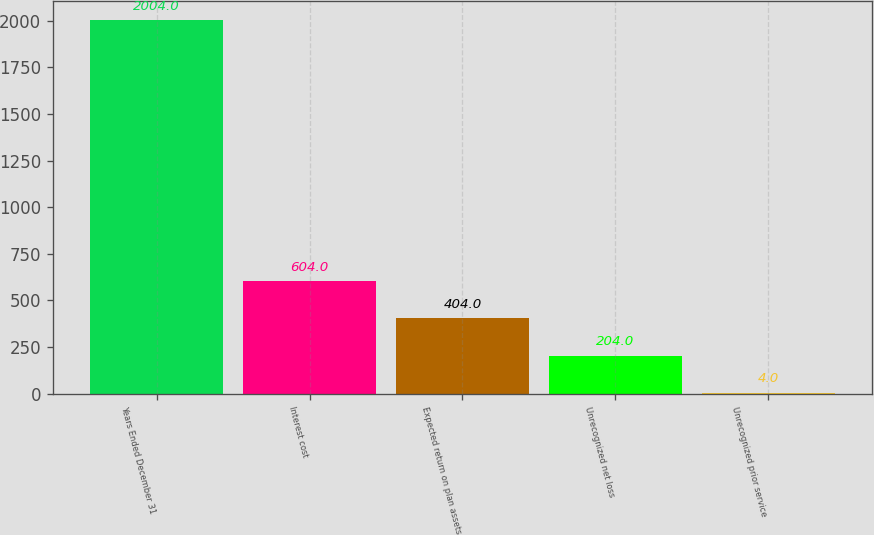Convert chart. <chart><loc_0><loc_0><loc_500><loc_500><bar_chart><fcel>Years Ended December 31<fcel>Interest cost<fcel>Expected return on plan assets<fcel>Unrecognized net loss<fcel>Unrecognized prior service<nl><fcel>2004<fcel>604<fcel>404<fcel>204<fcel>4<nl></chart> 